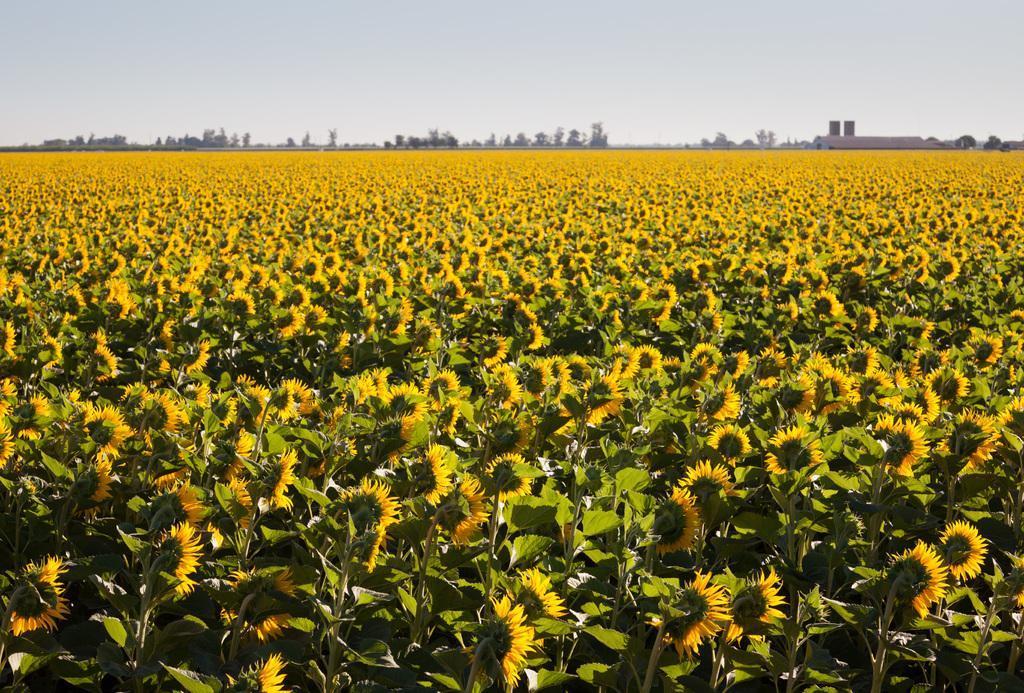How would you summarize this image in a sentence or two? In this image, we can see the land is filled with sunflowers, and in the middle we can see trees, house and the background is the sky. 